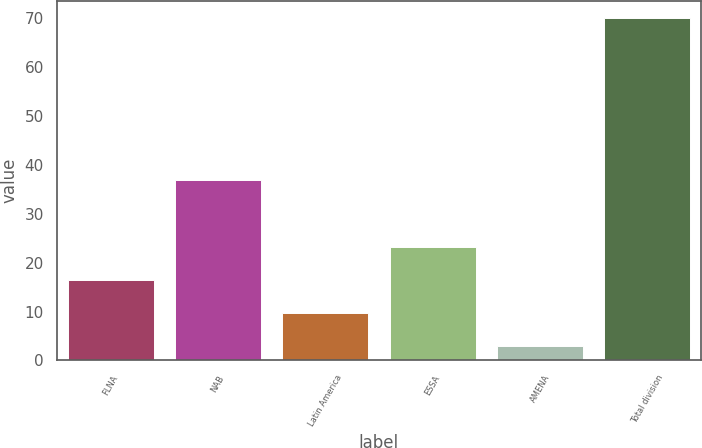Convert chart. <chart><loc_0><loc_0><loc_500><loc_500><bar_chart><fcel>FLNA<fcel>NAB<fcel>Latin America<fcel>ESSA<fcel>AMENA<fcel>Total division<nl><fcel>16.4<fcel>37<fcel>9.7<fcel>23.1<fcel>3<fcel>70<nl></chart> 